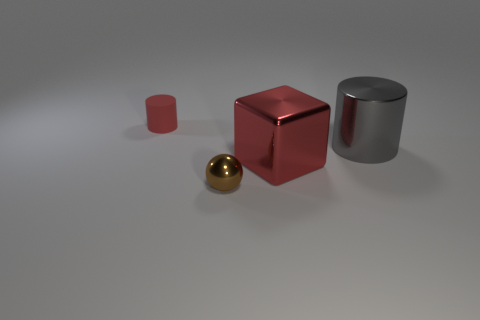Add 4 large blue matte cylinders. How many objects exist? 8 Subtract 0 cyan cylinders. How many objects are left? 4 Subtract all balls. How many objects are left? 3 Subtract all red metallic things. Subtract all blocks. How many objects are left? 2 Add 1 big gray shiny things. How many big gray shiny things are left? 2 Add 2 yellow metal cylinders. How many yellow metal cylinders exist? 2 